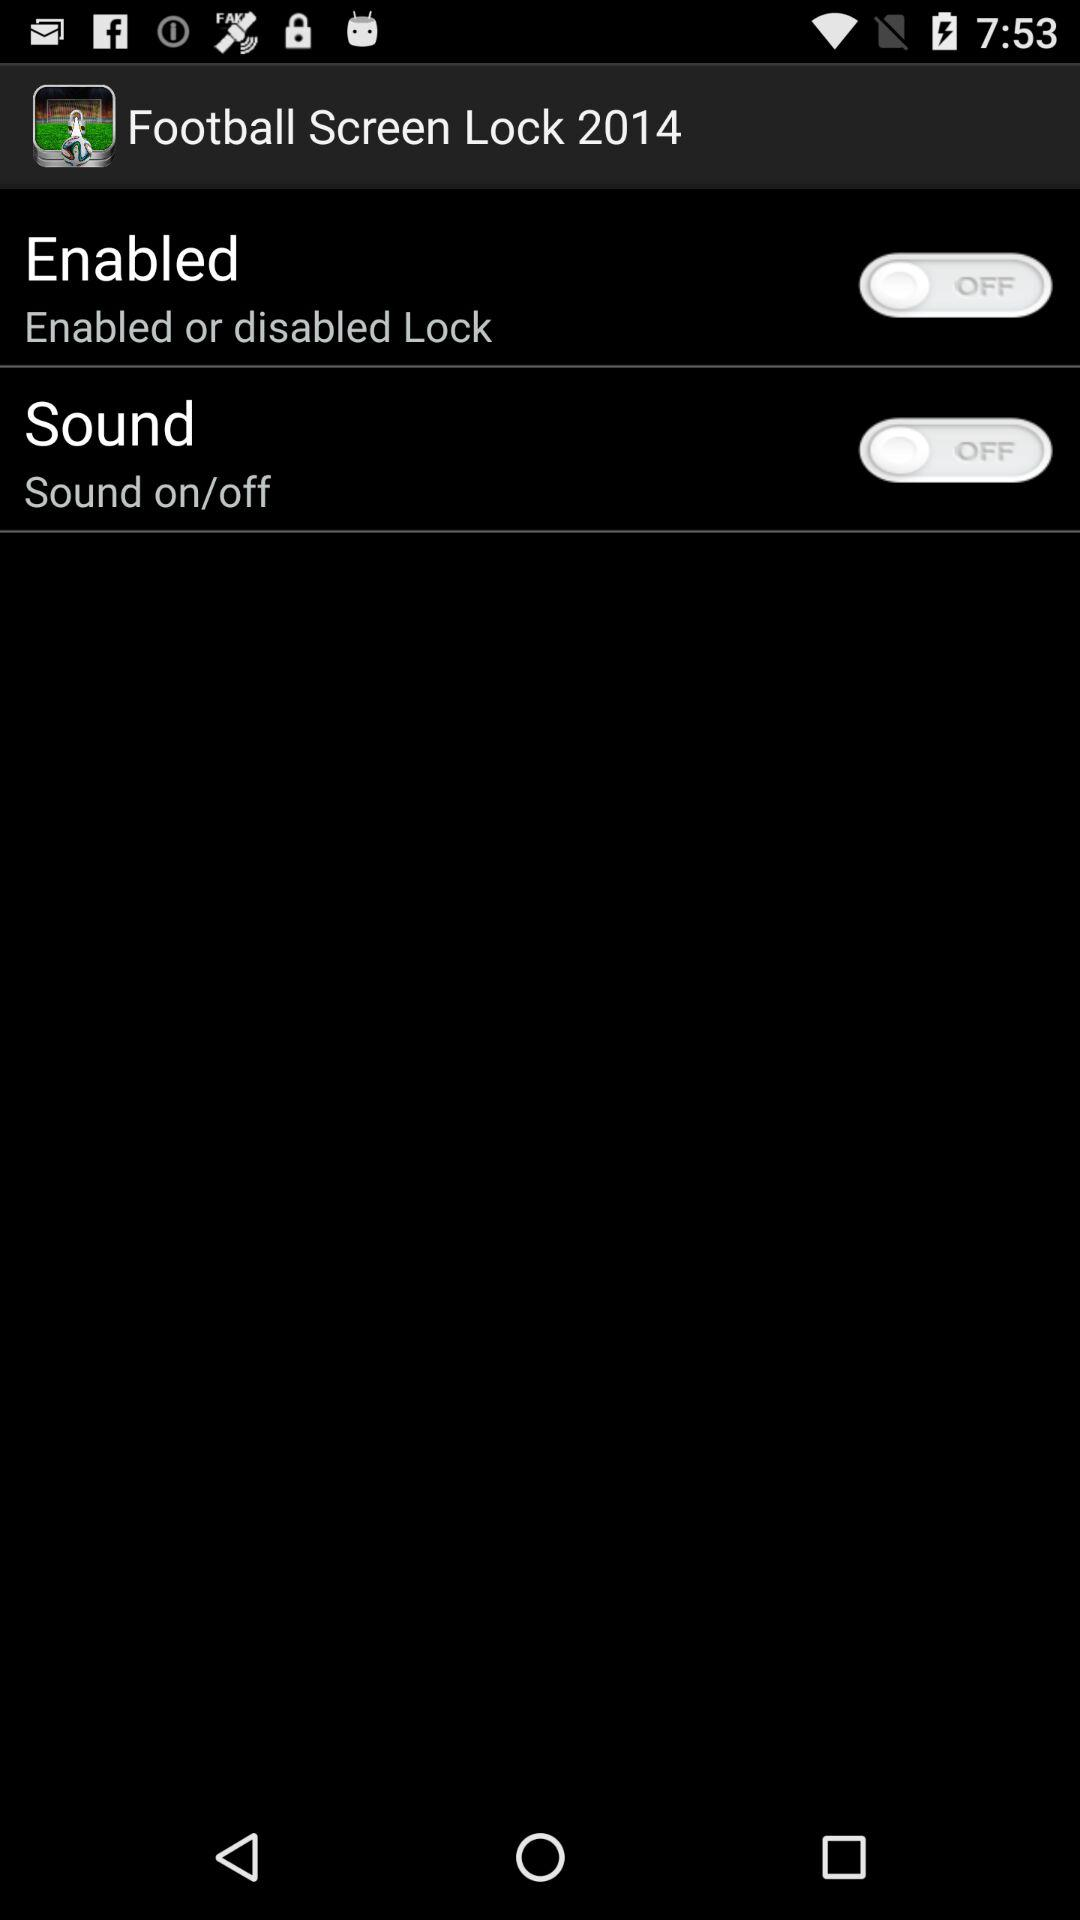How many switches are on this screen?
Answer the question using a single word or phrase. 2 